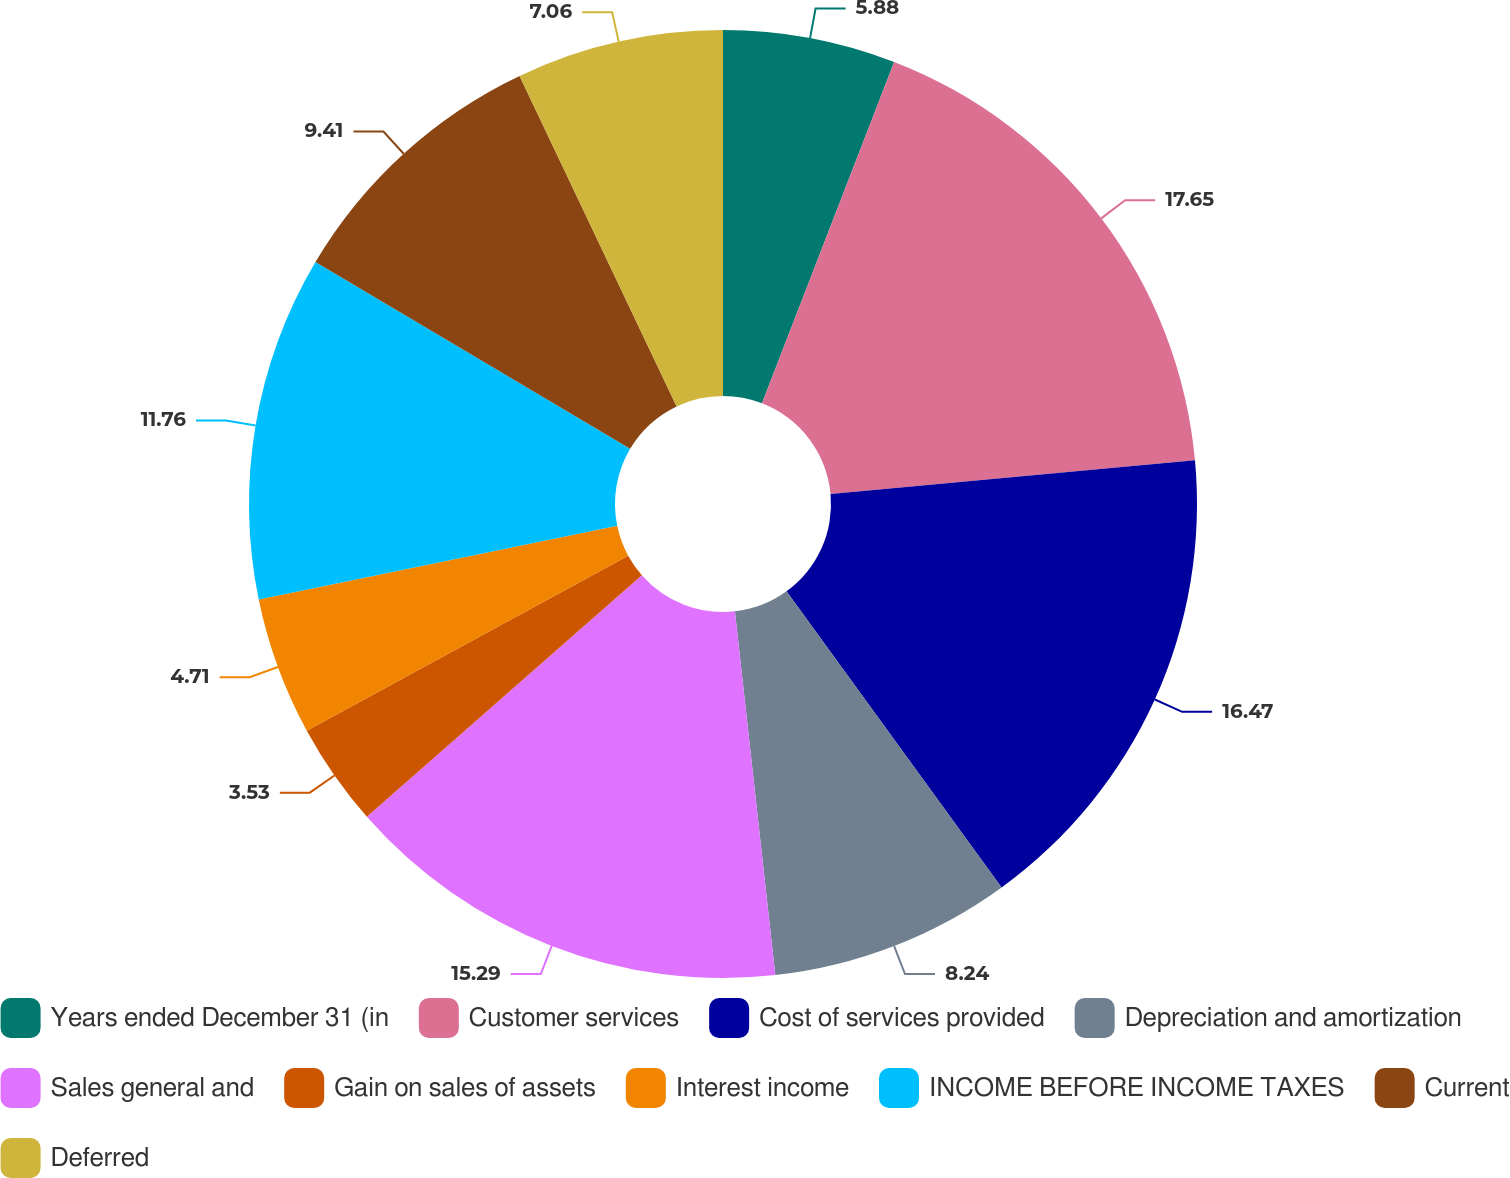<chart> <loc_0><loc_0><loc_500><loc_500><pie_chart><fcel>Years ended December 31 (in<fcel>Customer services<fcel>Cost of services provided<fcel>Depreciation and amortization<fcel>Sales general and<fcel>Gain on sales of assets<fcel>Interest income<fcel>INCOME BEFORE INCOME TAXES<fcel>Current<fcel>Deferred<nl><fcel>5.88%<fcel>17.65%<fcel>16.47%<fcel>8.24%<fcel>15.29%<fcel>3.53%<fcel>4.71%<fcel>11.76%<fcel>9.41%<fcel>7.06%<nl></chart> 